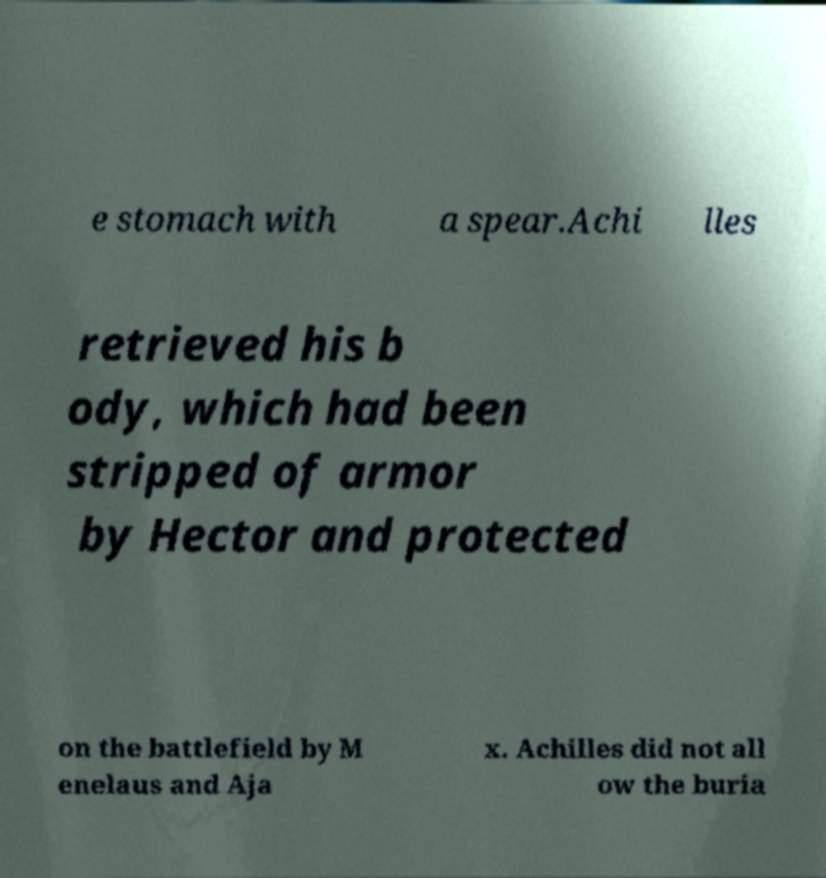I need the written content from this picture converted into text. Can you do that? e stomach with a spear.Achi lles retrieved his b ody, which had been stripped of armor by Hector and protected on the battlefield by M enelaus and Aja x. Achilles did not all ow the buria 